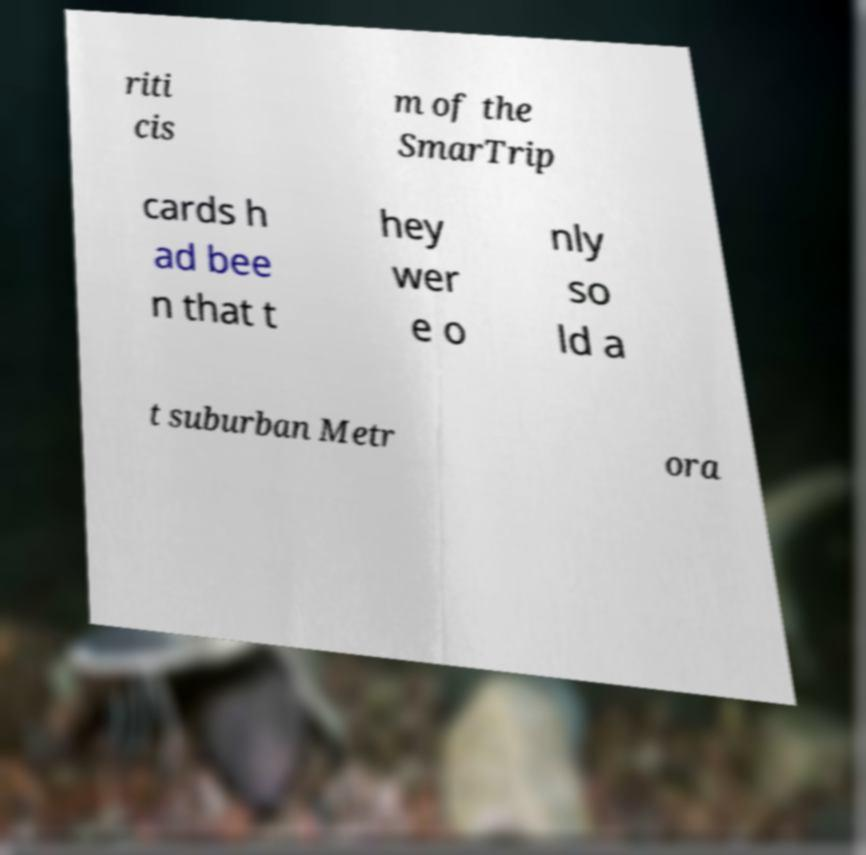Could you extract and type out the text from this image? riti cis m of the SmarTrip cards h ad bee n that t hey wer e o nly so ld a t suburban Metr ora 